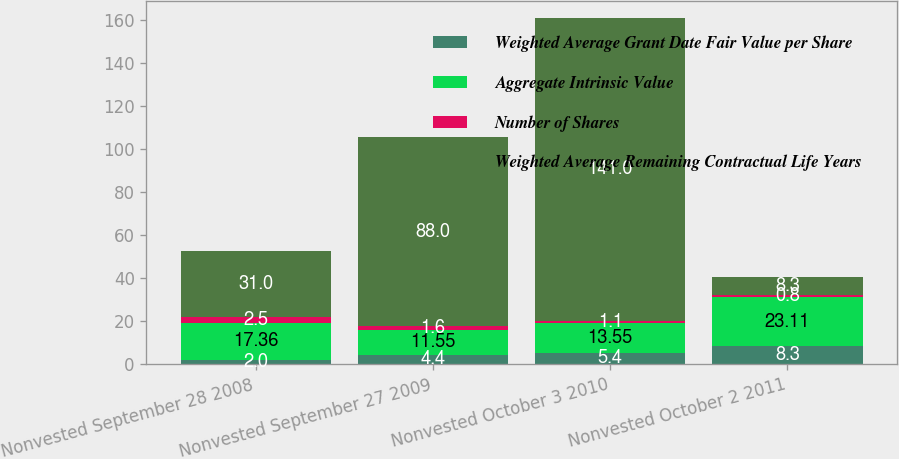Convert chart. <chart><loc_0><loc_0><loc_500><loc_500><stacked_bar_chart><ecel><fcel>Nonvested September 28 2008<fcel>Nonvested September 27 2009<fcel>Nonvested October 3 2010<fcel>Nonvested October 2 2011<nl><fcel>Weighted Average Grant Date Fair Value per Share<fcel>2<fcel>4.4<fcel>5.4<fcel>8.3<nl><fcel>Aggregate Intrinsic Value<fcel>17.36<fcel>11.55<fcel>13.55<fcel>23.11<nl><fcel>Number of Shares<fcel>2.5<fcel>1.6<fcel>1.1<fcel>0.8<nl><fcel>Weighted Average Remaining Contractual Life Years<fcel>31<fcel>88<fcel>141<fcel>8.3<nl></chart> 